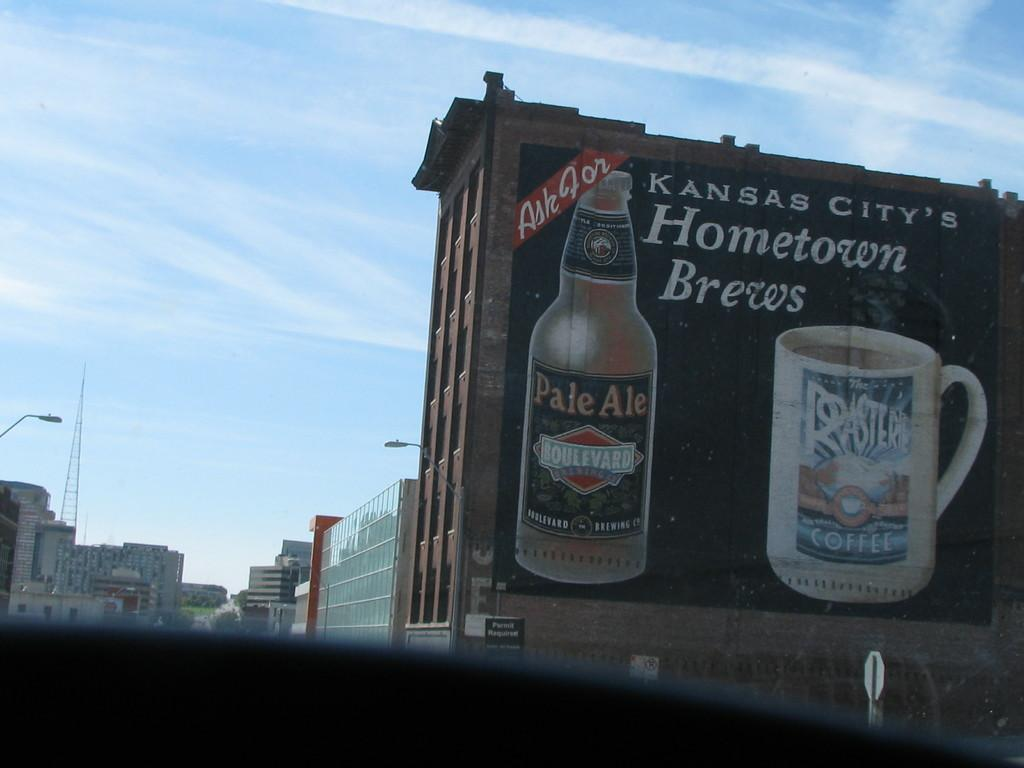<image>
Provide a brief description of the given image. A mural on the side of a brick building advertises Kansas City's Hometown brews. 